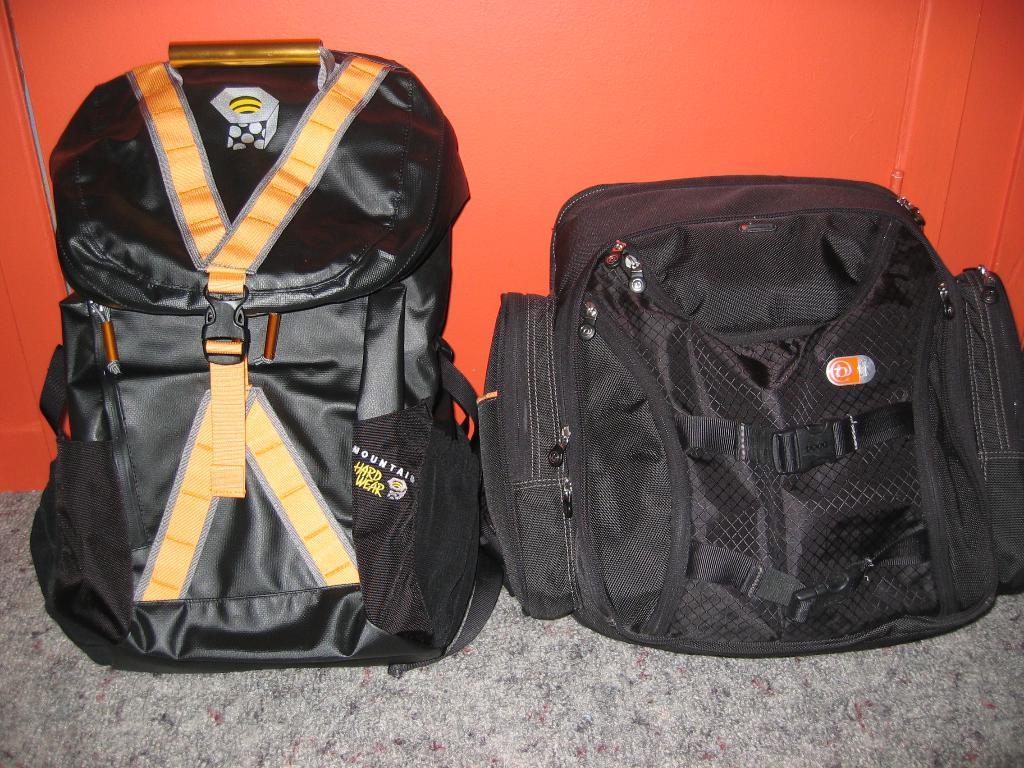In one or two sentences, can you explain what this image depicts? In this picture we can see two black color bags and for this bag we have straps, zips, handler and in background we can see orange color wall and this two bags are placed on floor. 